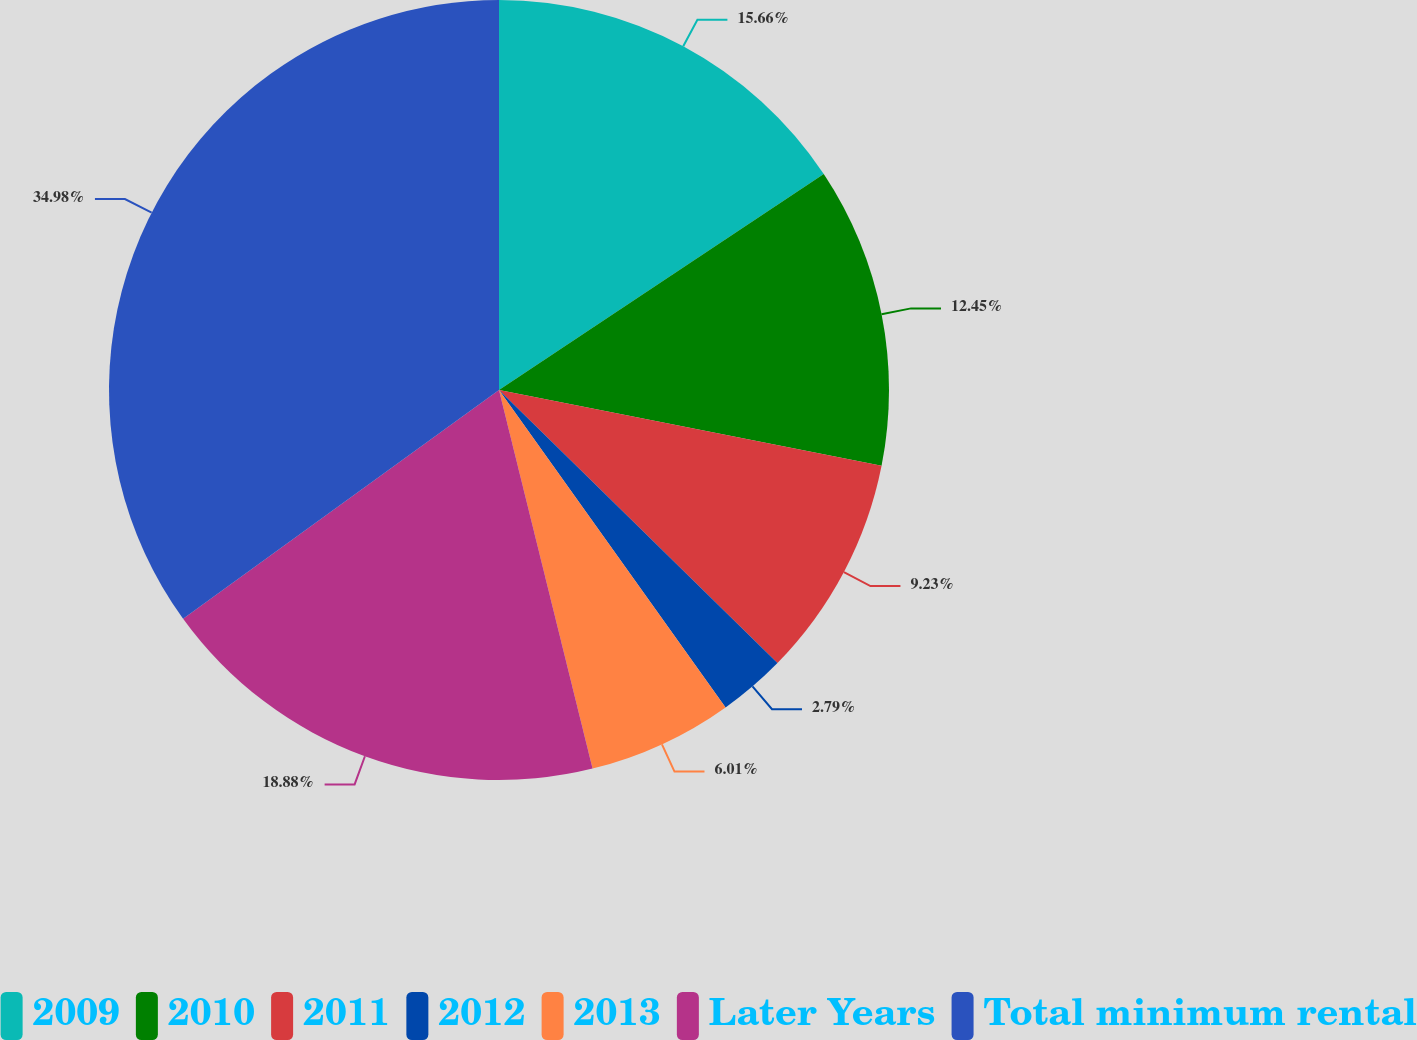<chart> <loc_0><loc_0><loc_500><loc_500><pie_chart><fcel>2009<fcel>2010<fcel>2011<fcel>2012<fcel>2013<fcel>Later Years<fcel>Total minimum rental<nl><fcel>15.66%<fcel>12.45%<fcel>9.23%<fcel>2.79%<fcel>6.01%<fcel>18.88%<fcel>34.97%<nl></chart> 